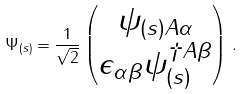<formula> <loc_0><loc_0><loc_500><loc_500>\Psi _ { ( s ) } = \frac { 1 } { \sqrt { 2 } } \begin{pmatrix} \psi _ { ( s ) A \alpha } \\ \epsilon _ { \alpha \beta } \psi _ { ( s ) } ^ { \dagger A \beta } \end{pmatrix} \, .</formula> 